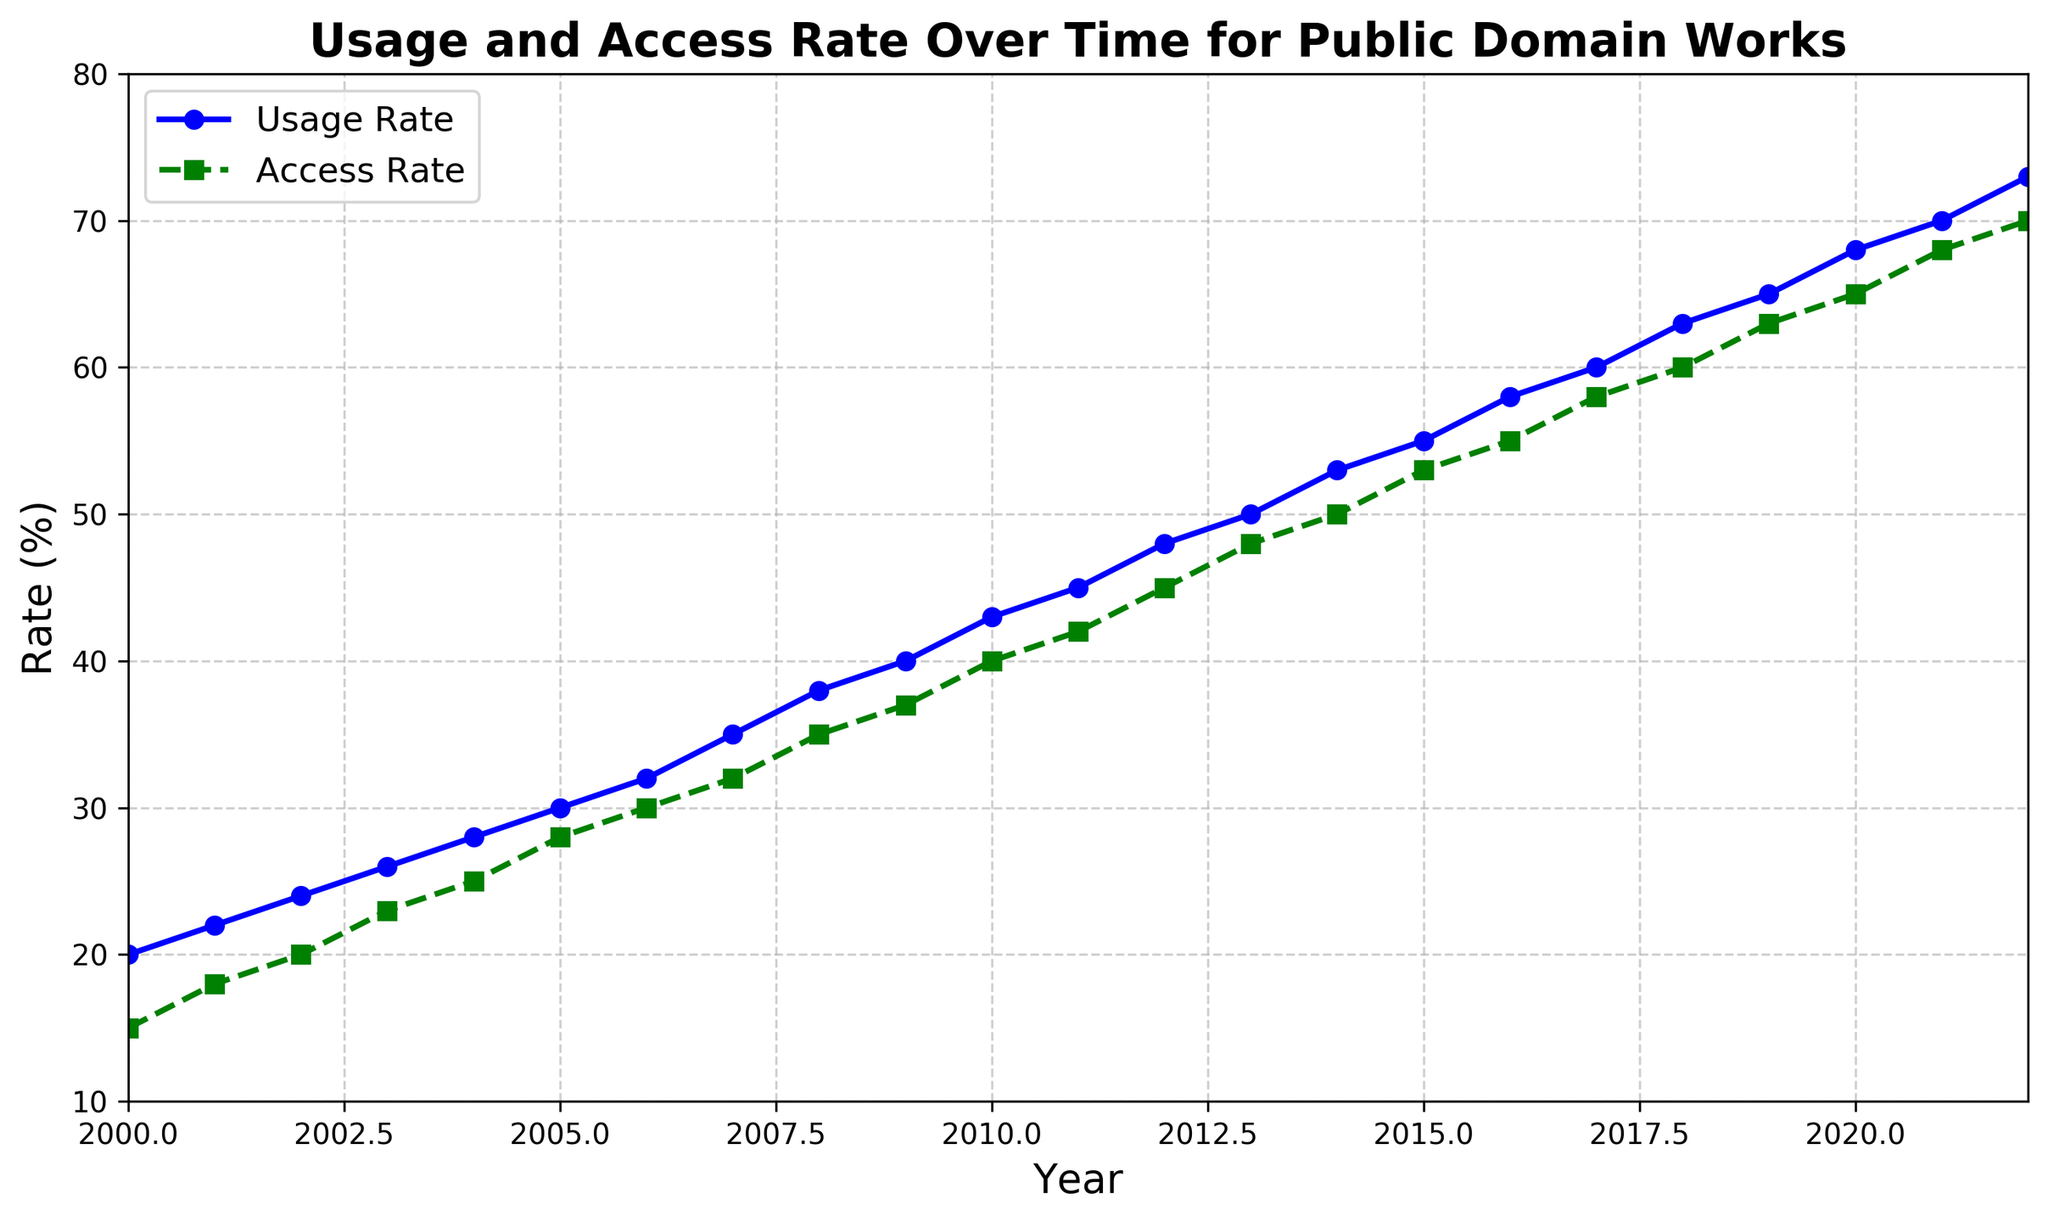Which year saw the highest usage rate within the given data? The usage rate is plotted with year values on the x-axis and usage rate values on the y-axis. The highest point in the usage rate curve corresponds to the year 2022.
Answer: 2022 In which year did the access rate reach 50%? The access rate curve shows the progression of access rates over the years. We find that the access rate hits 50% in 2014.
Answer: 2014 What's the difference between the usage rate and access rate in the year 2015? The usage rate for 2015 is 55%, and the access rate is 53%. The difference is calculated as 55% - 53%.
Answer: 2% Which rate saw a greater increase from 2000 to 2022, usage rate or access rate? From the graph, we can see that the usage rate increased from 20% in 2000 to 73% in 2022 (an increase of 53%), whereas the access rate increased from 15% in 2000 to 70% in 2022 (an increase of 55%).
Answer: Access rate How many years had a usage rate that was greater than a 40% but less than 60%? From the graph, we observe that the years with a usage rate between 40% and 60% (non-inclusive) are 2010, 2011, 2012, 2013, 2014, and 2015, which totals 6 years.
Answer: 6 What is the average access rate between 2010 and 2020 inclusive? The access rates between 2010 and 2020 are 40%, 42%, 45%, 48%, 50%, 53%, 55%, 58%, 60%, 63%, and 65%. The sum of these values is 529%. There are 11 years in this range, so the average is 529% / 11.
Answer: 48.1% In what year did the usage rate first exceed 32%? From the graph, we see that the usage rate first exceeds 32% in 2007 with a value of 35%.
Answer: 2007 What is the median of the access rate values plotted? The access rate values from 2000 to 2022 are in ascending order as [15, 18, 20, 23, 25, 28, 30, 32, 35, 37, 40, 42, 45, 48, 50, 53, 55, 58, 60, 63, 65, 68, 70]. With 23 data points, the median is the middle value, which is at the 12th position.
Answer: 42% 